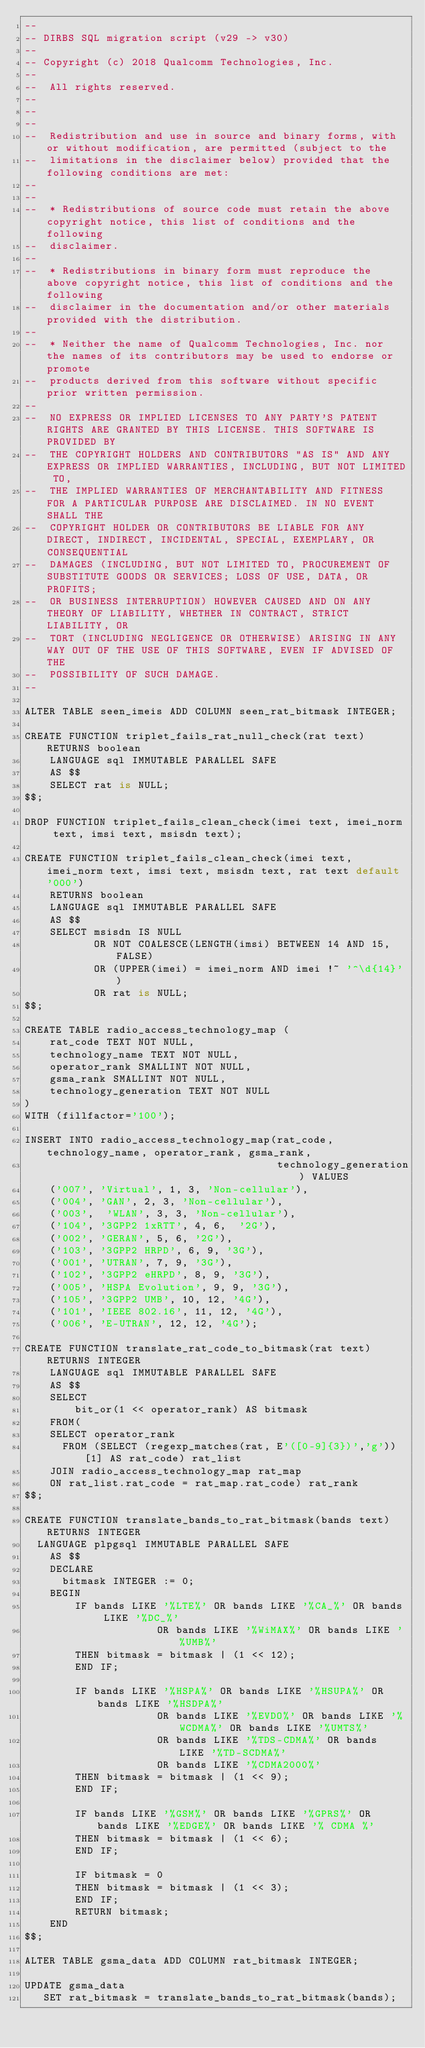Convert code to text. <code><loc_0><loc_0><loc_500><loc_500><_SQL_>--
-- DIRBS SQL migration script (v29 -> v30)
--
-- Copyright (c) 2018 Qualcomm Technologies, Inc.
--
--  All rights reserved.
--
--
--
--  Redistribution and use in source and binary forms, with or without modification, are permitted (subject to the
--  limitations in the disclaimer below) provided that the following conditions are met:
--
--
--  * Redistributions of source code must retain the above copyright notice, this list of conditions and the following
--  disclaimer.
--
--  * Redistributions in binary form must reproduce the above copyright notice, this list of conditions and the following
--  disclaimer in the documentation and/or other materials provided with the distribution.
--
--  * Neither the name of Qualcomm Technologies, Inc. nor the names of its contributors may be used to endorse or promote
--  products derived from this software without specific prior written permission.
--
--  NO EXPRESS OR IMPLIED LICENSES TO ANY PARTY'S PATENT RIGHTS ARE GRANTED BY THIS LICENSE. THIS SOFTWARE IS PROVIDED BY
--  THE COPYRIGHT HOLDERS AND CONTRIBUTORS "AS IS" AND ANY EXPRESS OR IMPLIED WARRANTIES, INCLUDING, BUT NOT LIMITED TO,
--  THE IMPLIED WARRANTIES OF MERCHANTABILITY AND FITNESS FOR A PARTICULAR PURPOSE ARE DISCLAIMED. IN NO EVENT SHALL THE
--  COPYRIGHT HOLDER OR CONTRIBUTORS BE LIABLE FOR ANY DIRECT, INDIRECT, INCIDENTAL, SPECIAL, EXEMPLARY, OR CONSEQUENTIAL
--  DAMAGES (INCLUDING, BUT NOT LIMITED TO, PROCUREMENT OF SUBSTITUTE GOODS OR SERVICES; LOSS OF USE, DATA, OR PROFITS;
--  OR BUSINESS INTERRUPTION) HOWEVER CAUSED AND ON ANY THEORY OF LIABILITY, WHETHER IN CONTRACT, STRICT LIABILITY, OR
--  TORT (INCLUDING NEGLIGENCE OR OTHERWISE) ARISING IN ANY WAY OUT OF THE USE OF THIS SOFTWARE, EVEN IF ADVISED OF THE
--  POSSIBILITY OF SUCH DAMAGE.
--

ALTER TABLE seen_imeis ADD COLUMN seen_rat_bitmask INTEGER;

CREATE FUNCTION triplet_fails_rat_null_check(rat text) RETURNS boolean
    LANGUAGE sql IMMUTABLE PARALLEL SAFE
    AS $$
    SELECT rat is NULL;
$$;

DROP FUNCTION triplet_fails_clean_check(imei text, imei_norm text, imsi text, msisdn text);

CREATE FUNCTION triplet_fails_clean_check(imei text, imei_norm text, imsi text, msisdn text, rat text default '000')
    RETURNS boolean
    LANGUAGE sql IMMUTABLE PARALLEL SAFE
    AS $$
    SELECT msisdn IS NULL
           OR NOT COALESCE(LENGTH(imsi) BETWEEN 14 AND 15, FALSE)
           OR (UPPER(imei) = imei_norm AND imei !~ '^\d{14}')
           OR rat is NULL;
$$;

CREATE TABLE radio_access_technology_map (
    rat_code TEXT NOT NULL,
    technology_name TEXT NOT NULL,
    operator_rank SMALLINT NOT NULL,
    gsma_rank SMALLINT NOT NULL,
    technology_generation TEXT NOT NULL
)
WITH (fillfactor='100');

INSERT INTO radio_access_technology_map(rat_code, technology_name, operator_rank, gsma_rank,
                                        technology_generation) VALUES
    ('007', 'Virtual', 1, 3, 'Non-cellular'),
    ('004', 'GAN', 2, 3, 'Non-cellular'),
    ('003',  'WLAN', 3, 3, 'Non-cellular'),
    ('104', '3GPP2 1xRTT', 4, 6,  '2G'),
    ('002', 'GERAN', 5, 6, '2G'),
    ('103', '3GPP2 HRPD', 6, 9, '3G'),
    ('001', 'UTRAN', 7, 9, '3G'),
    ('102', '3GPP2 eHRPD', 8, 9, '3G'),
    ('005', 'HSPA Evolution', 9, 9, '3G'),
    ('105', '3GPP2 UMB', 10, 12, '4G'),
    ('101', 'IEEE 802.16', 11, 12, '4G'),
    ('006', 'E-UTRAN', 12, 12, '4G');

CREATE FUNCTION translate_rat_code_to_bitmask(rat text) RETURNS INTEGER
    LANGUAGE sql IMMUTABLE PARALLEL SAFE
    AS $$
    SELECT
        bit_or(1 << operator_rank) AS bitmask
    FROM(
    SELECT operator_rank
      FROM (SELECT (regexp_matches(rat, E'([0-9]{3})','g'))[1] AS rat_code) rat_list
    JOIN radio_access_technology_map rat_map
    ON rat_list.rat_code = rat_map.rat_code) rat_rank
$$;

CREATE FUNCTION translate_bands_to_rat_bitmask(bands text) RETURNS INTEGER
  LANGUAGE plpgsql IMMUTABLE PARALLEL SAFE
    AS $$
    DECLARE
      bitmask INTEGER := 0;
    BEGIN
        IF bands LIKE '%LTE%' OR bands LIKE '%CA_%' OR bands LIKE '%DC_%'
                     OR bands LIKE '%WiMAX%' OR bands LIKE '%UMB%'
        THEN bitmask = bitmask | (1 << 12);
        END IF;

        IF bands LIKE '%HSPA%' OR bands LIKE '%HSUPA%' OR bands LIKE '%HSDPA%'
                     OR bands LIKE '%EVDO%' OR bands LIKE '%WCDMA%' OR bands LIKE '%UMTS%'
                     OR bands LIKE '%TDS-CDMA%' OR bands LIKE '%TD-SCDMA%'
                     OR bands LIKE '%CDMA2000%'
        THEN bitmask = bitmask | (1 << 9);
        END IF;

        IF bands LIKE '%GSM%' OR bands LIKE '%GPRS%' OR bands LIKE '%EDGE%' OR bands LIKE '% CDMA %'
        THEN bitmask = bitmask | (1 << 6);
        END IF;

        IF bitmask = 0
        THEN bitmask = bitmask | (1 << 3);
        END IF;
        RETURN bitmask;
    END
$$;

ALTER TABLE gsma_data ADD COLUMN rat_bitmask INTEGER;

UPDATE gsma_data
   SET rat_bitmask = translate_bands_to_rat_bitmask(bands);
</code> 